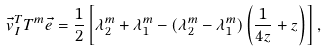Convert formula to latex. <formula><loc_0><loc_0><loc_500><loc_500>\vec { v } _ { I } ^ { T } T ^ { m } \vec { e } = \frac { 1 } { 2 } \left [ \lambda _ { 2 } ^ { m } + \lambda _ { 1 } ^ { m } - ( \lambda _ { 2 } ^ { m } - \lambda _ { 1 } ^ { m } ) \left ( \frac { 1 } { 4 z } + z \right ) \right ] ,</formula> 